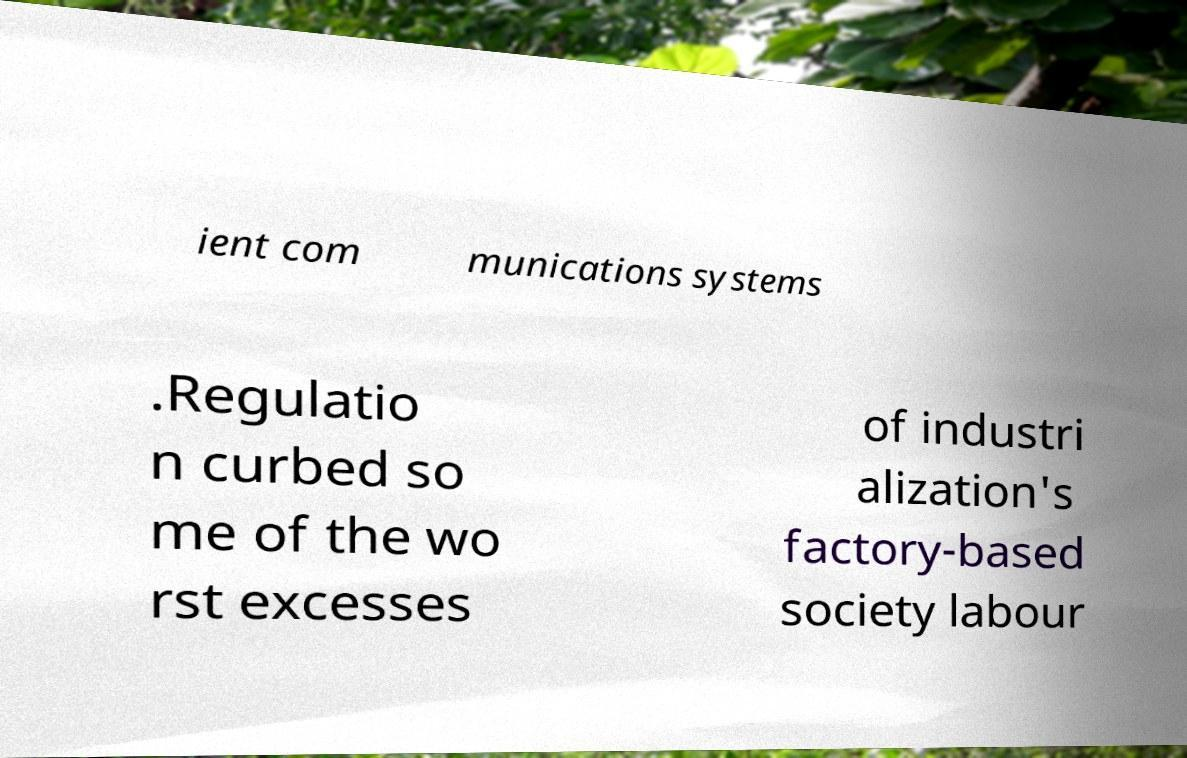What messages or text are displayed in this image? I need them in a readable, typed format. ient com munications systems .Regulatio n curbed so me of the wo rst excesses of industri alization's factory-based society labour 